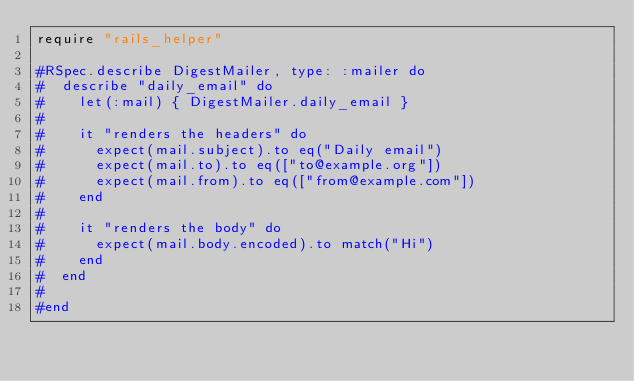<code> <loc_0><loc_0><loc_500><loc_500><_Ruby_>require "rails_helper"

#RSpec.describe DigestMailer, type: :mailer do
#  describe "daily_email" do
#    let(:mail) { DigestMailer.daily_email }
#
#    it "renders the headers" do
#      expect(mail.subject).to eq("Daily email")
#      expect(mail.to).to eq(["to@example.org"])
#      expect(mail.from).to eq(["from@example.com"])
#    end
#
#    it "renders the body" do
#      expect(mail.body.encoded).to match("Hi")
#    end
#  end
#
#end
</code> 